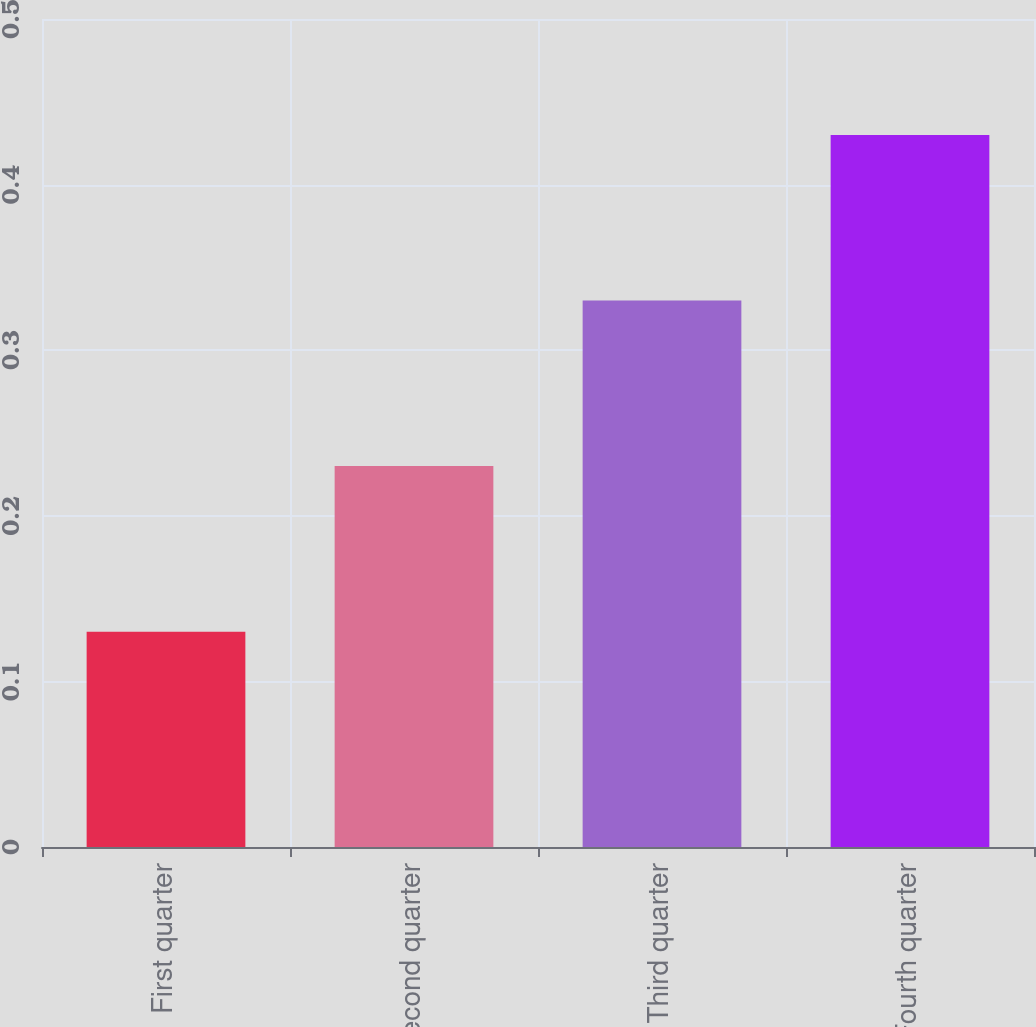Convert chart to OTSL. <chart><loc_0><loc_0><loc_500><loc_500><bar_chart><fcel>First quarter<fcel>Second quarter<fcel>Third quarter<fcel>Fourth quarter<nl><fcel>0.13<fcel>0.23<fcel>0.33<fcel>0.43<nl></chart> 